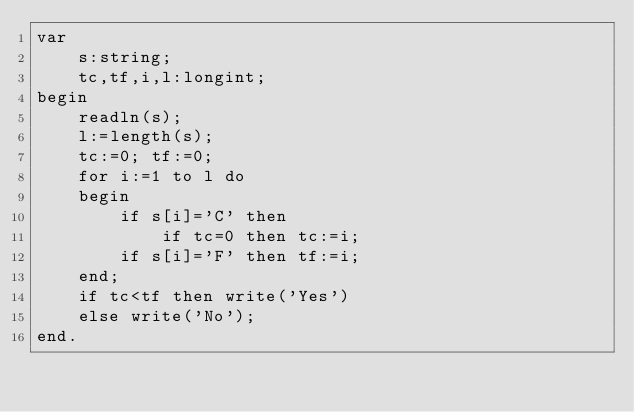Convert code to text. <code><loc_0><loc_0><loc_500><loc_500><_Pascal_>var
    s:string;
    tc,tf,i,l:longint;
begin
    readln(s);
    l:=length(s);
    tc:=0; tf:=0;
    for i:=1 to l do
    begin
        if s[i]='C' then
            if tc=0 then tc:=i;
        if s[i]='F' then tf:=i;
    end;
    if tc<tf then write('Yes')
    else write('No');
end.</code> 